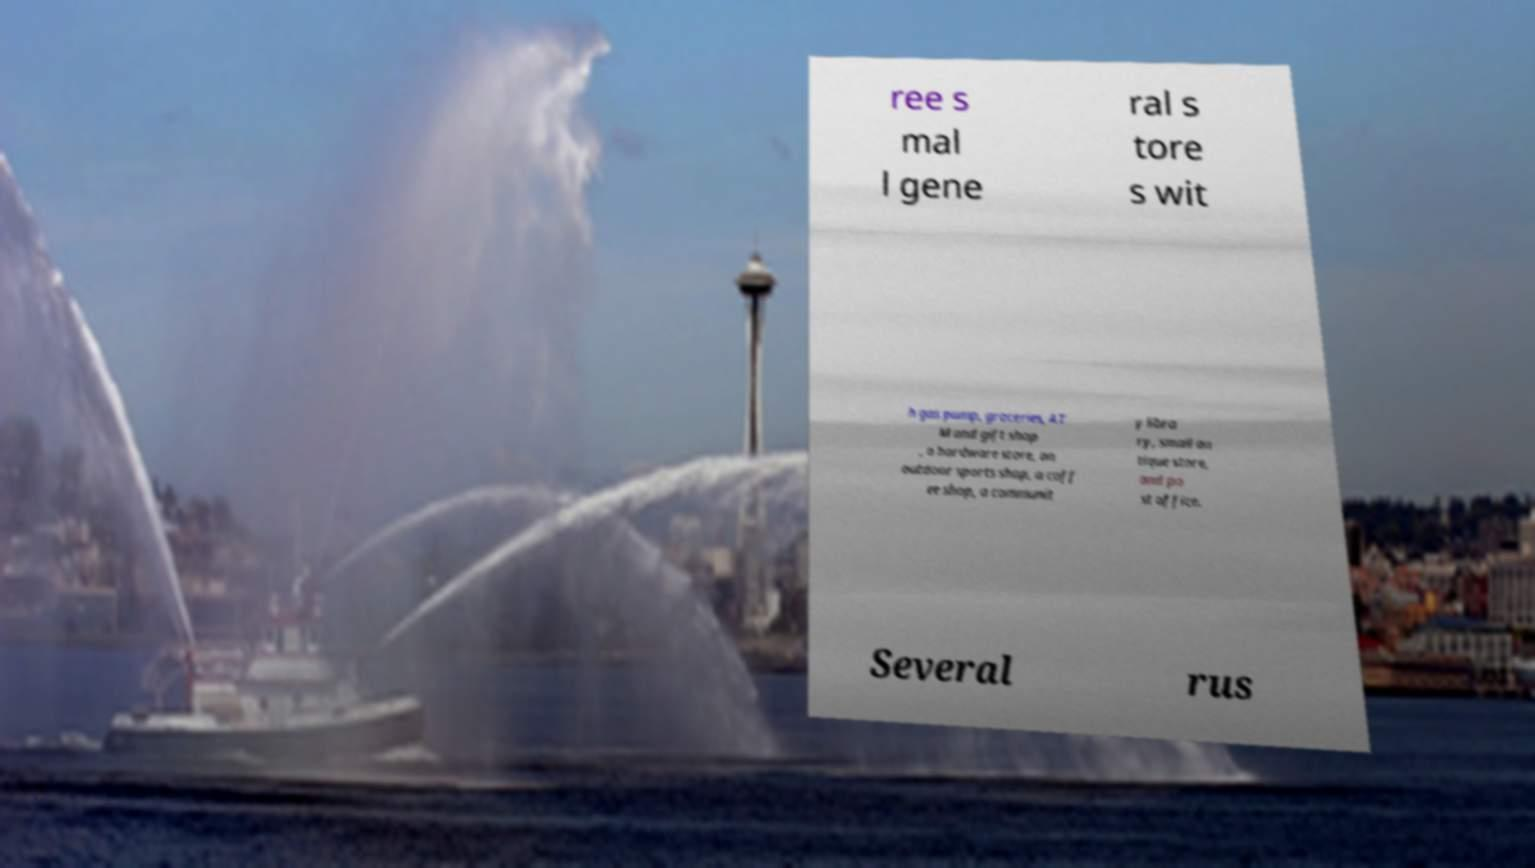Please read and relay the text visible in this image. What does it say? ree s mal l gene ral s tore s wit h gas pump, groceries, AT M and gift shop , a hardware store, an outdoor sports shop, a coff ee shop, a communit y libra ry, small an tique store, and po st office. Several rus 